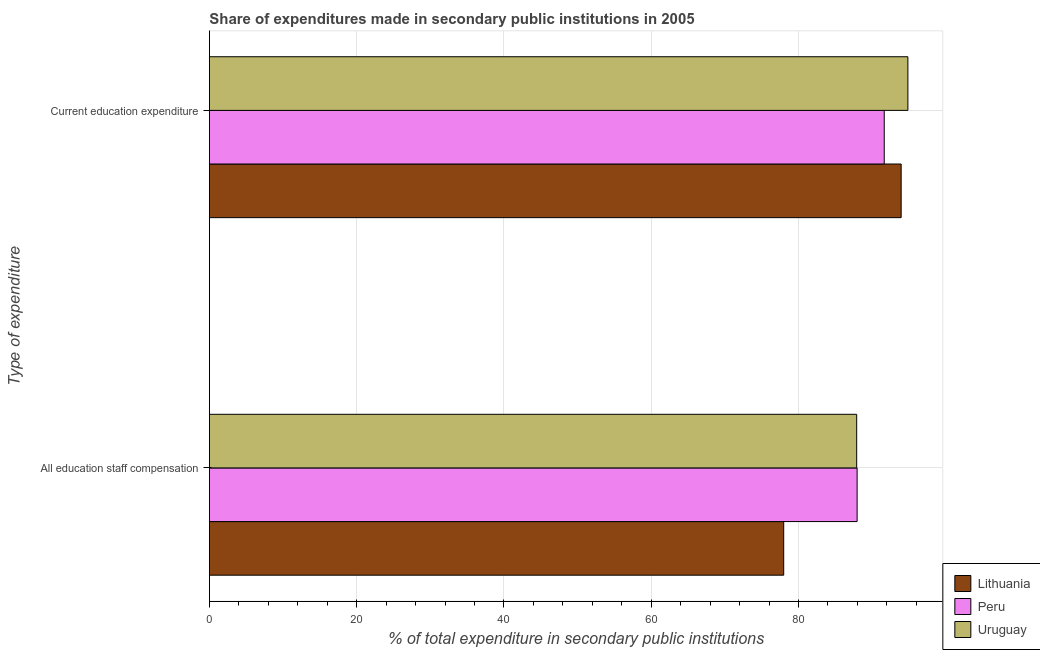How many groups of bars are there?
Make the answer very short. 2. Are the number of bars per tick equal to the number of legend labels?
Ensure brevity in your answer.  Yes. How many bars are there on the 1st tick from the top?
Provide a succinct answer. 3. What is the label of the 1st group of bars from the top?
Ensure brevity in your answer.  Current education expenditure. What is the expenditure in staff compensation in Uruguay?
Ensure brevity in your answer.  87.9. Across all countries, what is the maximum expenditure in education?
Keep it short and to the point. 94.86. Across all countries, what is the minimum expenditure in education?
Your answer should be compact. 91.65. In which country was the expenditure in education minimum?
Give a very brief answer. Peru. What is the total expenditure in education in the graph?
Offer a terse response. 280.45. What is the difference between the expenditure in staff compensation in Peru and that in Lithuania?
Provide a short and direct response. 9.97. What is the difference between the expenditure in staff compensation in Uruguay and the expenditure in education in Peru?
Offer a very short reply. -3.74. What is the average expenditure in education per country?
Your answer should be compact. 93.48. What is the difference between the expenditure in staff compensation and expenditure in education in Uruguay?
Keep it short and to the point. -6.95. In how many countries, is the expenditure in education greater than 72 %?
Keep it short and to the point. 3. What is the ratio of the expenditure in education in Peru to that in Lithuania?
Make the answer very short. 0.98. In how many countries, is the expenditure in education greater than the average expenditure in education taken over all countries?
Your answer should be very brief. 2. What does the 3rd bar from the top in Current education expenditure represents?
Offer a terse response. Lithuania. What does the 1st bar from the bottom in All education staff compensation represents?
Offer a terse response. Lithuania. How many bars are there?
Your answer should be compact. 6. Are all the bars in the graph horizontal?
Your answer should be very brief. Yes. How many countries are there in the graph?
Offer a terse response. 3. Where does the legend appear in the graph?
Offer a very short reply. Bottom right. How many legend labels are there?
Make the answer very short. 3. How are the legend labels stacked?
Your response must be concise. Vertical. What is the title of the graph?
Your response must be concise. Share of expenditures made in secondary public institutions in 2005. Does "Tuvalu" appear as one of the legend labels in the graph?
Provide a short and direct response. No. What is the label or title of the X-axis?
Make the answer very short. % of total expenditure in secondary public institutions. What is the label or title of the Y-axis?
Your response must be concise. Type of expenditure. What is the % of total expenditure in secondary public institutions of Lithuania in All education staff compensation?
Give a very brief answer. 77.99. What is the % of total expenditure in secondary public institutions of Peru in All education staff compensation?
Your response must be concise. 87.96. What is the % of total expenditure in secondary public institutions of Uruguay in All education staff compensation?
Provide a short and direct response. 87.9. What is the % of total expenditure in secondary public institutions of Lithuania in Current education expenditure?
Your response must be concise. 93.94. What is the % of total expenditure in secondary public institutions in Peru in Current education expenditure?
Keep it short and to the point. 91.65. What is the % of total expenditure in secondary public institutions in Uruguay in Current education expenditure?
Provide a short and direct response. 94.86. Across all Type of expenditure, what is the maximum % of total expenditure in secondary public institutions in Lithuania?
Offer a terse response. 93.94. Across all Type of expenditure, what is the maximum % of total expenditure in secondary public institutions in Peru?
Give a very brief answer. 91.65. Across all Type of expenditure, what is the maximum % of total expenditure in secondary public institutions in Uruguay?
Your answer should be compact. 94.86. Across all Type of expenditure, what is the minimum % of total expenditure in secondary public institutions of Lithuania?
Ensure brevity in your answer.  77.99. Across all Type of expenditure, what is the minimum % of total expenditure in secondary public institutions in Peru?
Your response must be concise. 87.96. Across all Type of expenditure, what is the minimum % of total expenditure in secondary public institutions in Uruguay?
Your answer should be compact. 87.9. What is the total % of total expenditure in secondary public institutions of Lithuania in the graph?
Offer a terse response. 171.94. What is the total % of total expenditure in secondary public institutions in Peru in the graph?
Keep it short and to the point. 179.61. What is the total % of total expenditure in secondary public institutions of Uruguay in the graph?
Offer a very short reply. 182.76. What is the difference between the % of total expenditure in secondary public institutions in Lithuania in All education staff compensation and that in Current education expenditure?
Provide a short and direct response. -15.95. What is the difference between the % of total expenditure in secondary public institutions in Peru in All education staff compensation and that in Current education expenditure?
Offer a very short reply. -3.68. What is the difference between the % of total expenditure in secondary public institutions of Uruguay in All education staff compensation and that in Current education expenditure?
Ensure brevity in your answer.  -6.95. What is the difference between the % of total expenditure in secondary public institutions of Lithuania in All education staff compensation and the % of total expenditure in secondary public institutions of Peru in Current education expenditure?
Your answer should be compact. -13.65. What is the difference between the % of total expenditure in secondary public institutions of Lithuania in All education staff compensation and the % of total expenditure in secondary public institutions of Uruguay in Current education expenditure?
Make the answer very short. -16.87. What is the difference between the % of total expenditure in secondary public institutions in Peru in All education staff compensation and the % of total expenditure in secondary public institutions in Uruguay in Current education expenditure?
Your response must be concise. -6.9. What is the average % of total expenditure in secondary public institutions in Lithuania per Type of expenditure?
Offer a very short reply. 85.97. What is the average % of total expenditure in secondary public institutions of Peru per Type of expenditure?
Give a very brief answer. 89.8. What is the average % of total expenditure in secondary public institutions of Uruguay per Type of expenditure?
Your response must be concise. 91.38. What is the difference between the % of total expenditure in secondary public institutions in Lithuania and % of total expenditure in secondary public institutions in Peru in All education staff compensation?
Offer a terse response. -9.97. What is the difference between the % of total expenditure in secondary public institutions of Lithuania and % of total expenditure in secondary public institutions of Uruguay in All education staff compensation?
Ensure brevity in your answer.  -9.91. What is the difference between the % of total expenditure in secondary public institutions of Peru and % of total expenditure in secondary public institutions of Uruguay in All education staff compensation?
Offer a very short reply. 0.06. What is the difference between the % of total expenditure in secondary public institutions of Lithuania and % of total expenditure in secondary public institutions of Peru in Current education expenditure?
Your answer should be compact. 2.3. What is the difference between the % of total expenditure in secondary public institutions of Lithuania and % of total expenditure in secondary public institutions of Uruguay in Current education expenditure?
Give a very brief answer. -0.92. What is the difference between the % of total expenditure in secondary public institutions of Peru and % of total expenditure in secondary public institutions of Uruguay in Current education expenditure?
Provide a short and direct response. -3.21. What is the ratio of the % of total expenditure in secondary public institutions in Lithuania in All education staff compensation to that in Current education expenditure?
Provide a succinct answer. 0.83. What is the ratio of the % of total expenditure in secondary public institutions of Peru in All education staff compensation to that in Current education expenditure?
Your response must be concise. 0.96. What is the ratio of the % of total expenditure in secondary public institutions of Uruguay in All education staff compensation to that in Current education expenditure?
Provide a short and direct response. 0.93. What is the difference between the highest and the second highest % of total expenditure in secondary public institutions of Lithuania?
Make the answer very short. 15.95. What is the difference between the highest and the second highest % of total expenditure in secondary public institutions in Peru?
Ensure brevity in your answer.  3.68. What is the difference between the highest and the second highest % of total expenditure in secondary public institutions in Uruguay?
Offer a very short reply. 6.95. What is the difference between the highest and the lowest % of total expenditure in secondary public institutions in Lithuania?
Your answer should be compact. 15.95. What is the difference between the highest and the lowest % of total expenditure in secondary public institutions in Peru?
Give a very brief answer. 3.68. What is the difference between the highest and the lowest % of total expenditure in secondary public institutions in Uruguay?
Give a very brief answer. 6.95. 